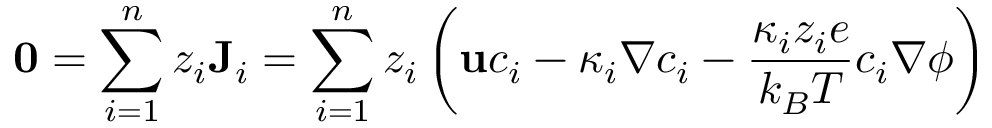<formula> <loc_0><loc_0><loc_500><loc_500>0 = \sum _ { i = 1 } ^ { n } z _ { i } J _ { i } = \sum _ { i = 1 } ^ { n } z _ { i } \left ( u c _ { i } - \kappa _ { i } \nabla c _ { i } - \frac { \kappa _ { i } z _ { i } e } { k _ { B } T } c _ { i } \nabla \phi \right )</formula> 